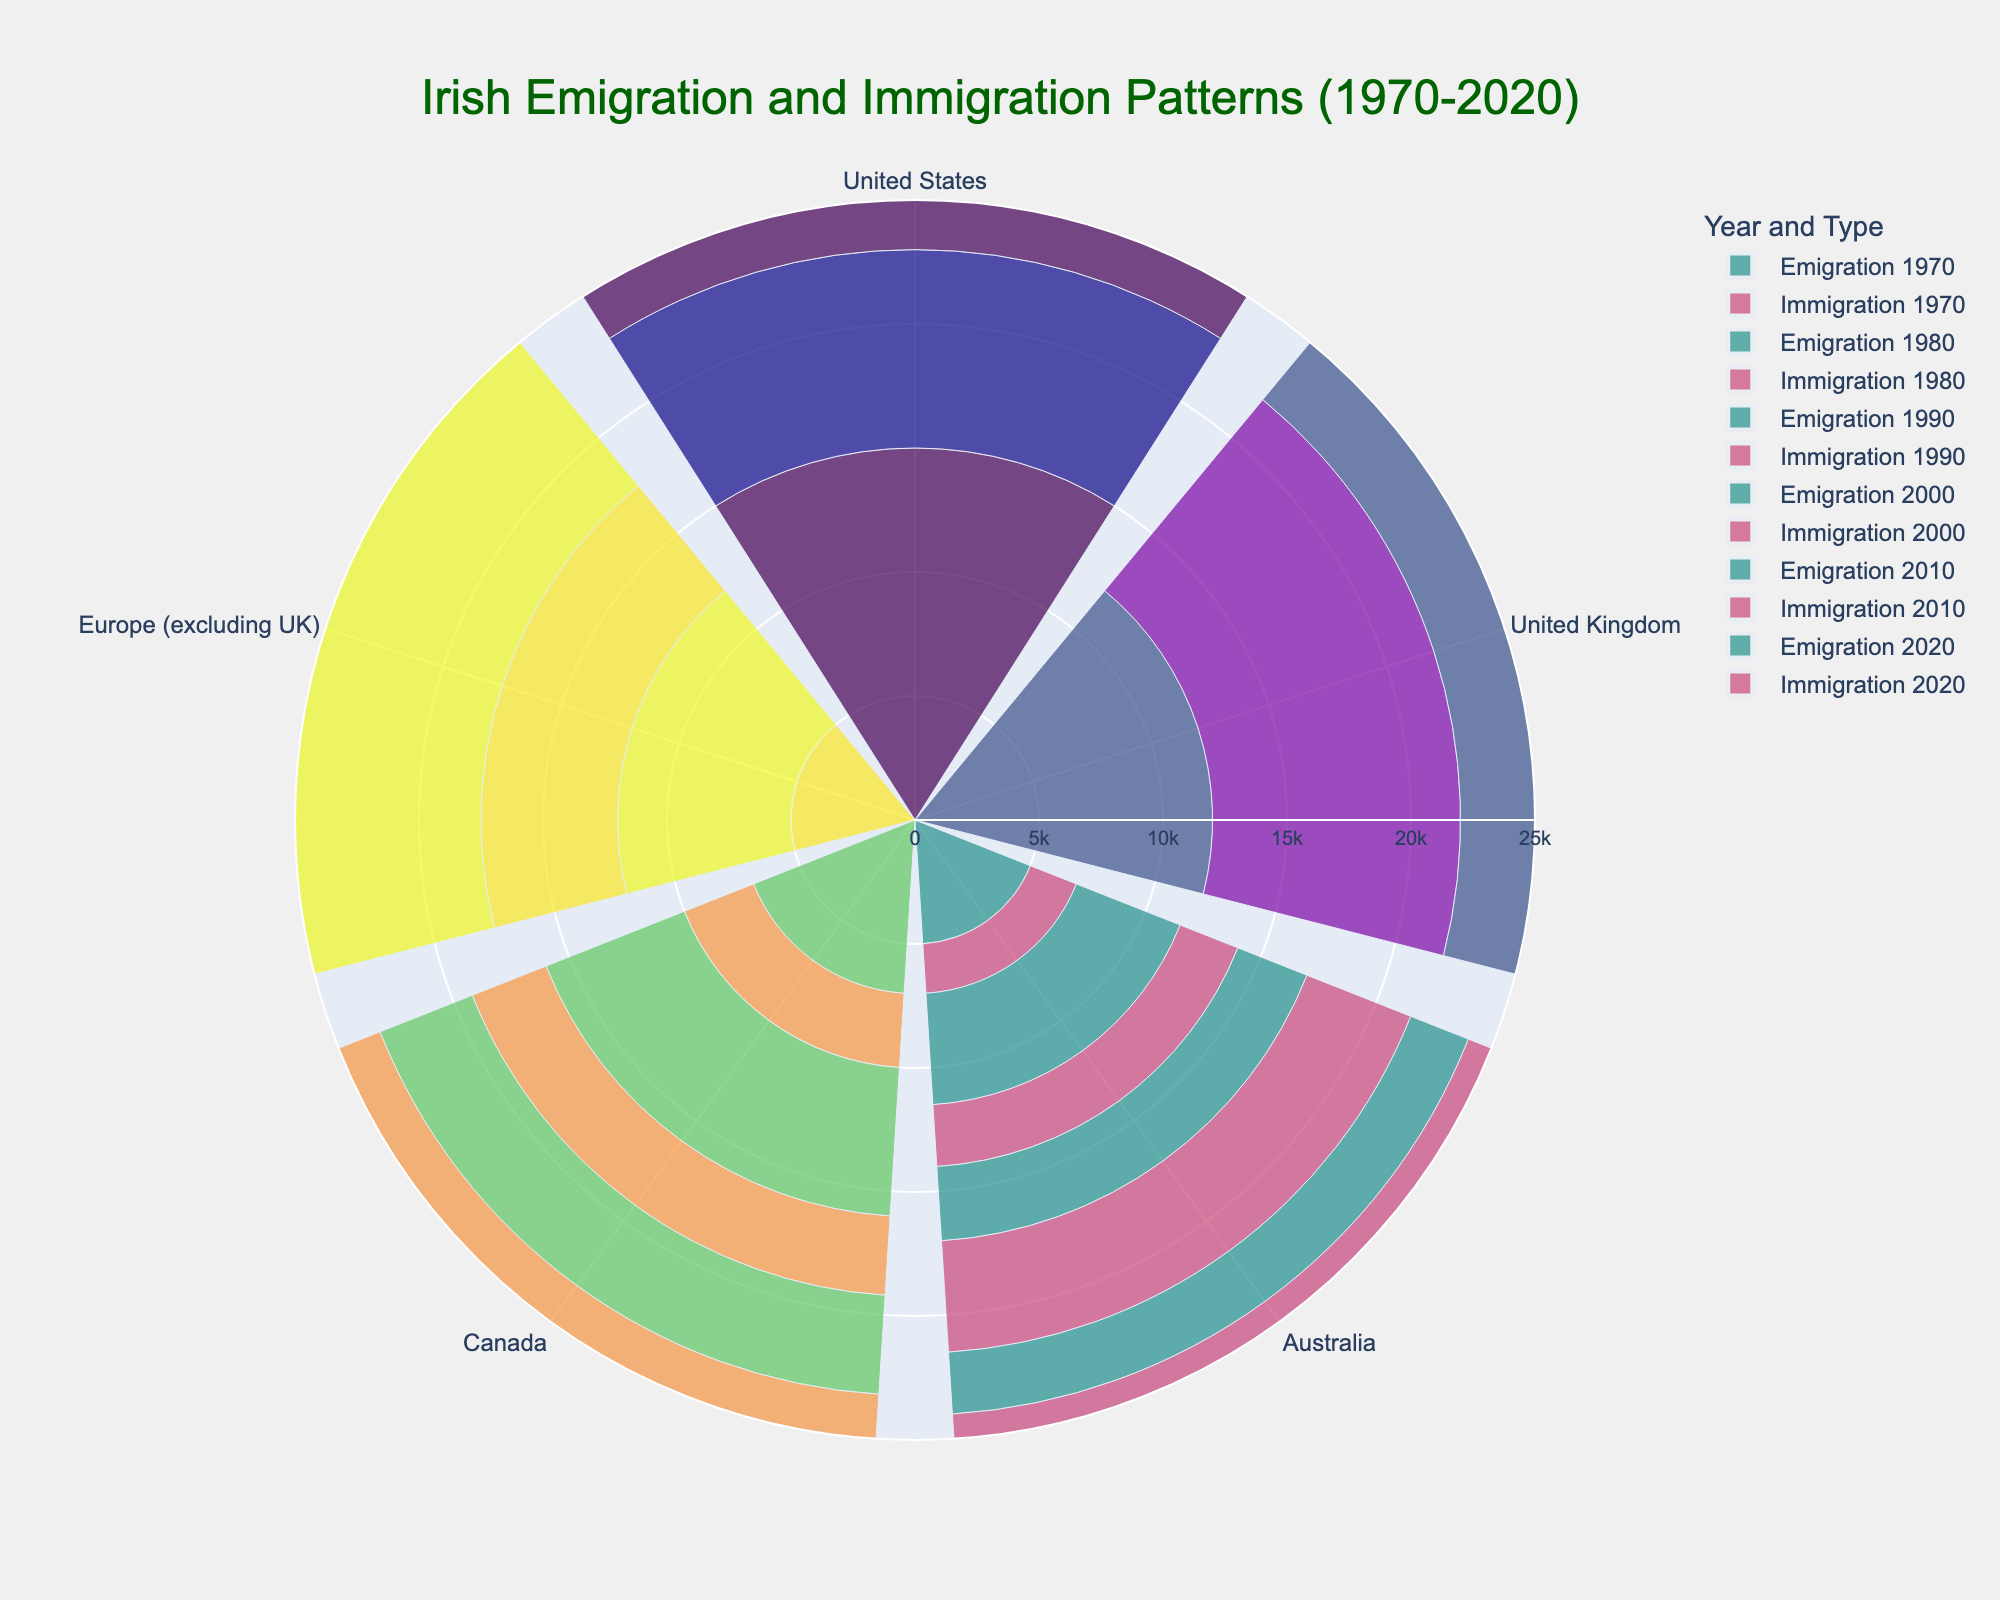What's the title of the chart? At the top of the chart, there is a text box that provides the title, which summarizes the content of the chart.
Answer: Irish Emigration and Immigration Patterns (1970-2020) How many regions are shown in the chart? The chart divides the data into segments, each representing a region. By counting these segments, we can determine the number of regions.
Answer: 5 Which region had the highest immigration in 2020? The bar segments labeled "Immigration 2020" extend outwards from the center. By identifying the longest bar, we can determine which region had the highest immigration.
Answer: United States What is the difference in emigration between the United Kingdom and Europe (excluding UK) in 2010? Look at the "Emigration 2010" bars for both regions and subtract the value of Europe (excluding UK) from the United Kingdom.
Answer: -1000 Which year did Canada have higher immigration compared to emigration most significantly? Compare the lengths of the "Immigration" and "Emigration" bars for Canada across all years. Identify the year with the largest difference where immigration is greater than emigration.
Answer: 2000 In which year did Australia see the least emigration? Look at the "Emigration" bars for Australia in all years and find the shortest bar.
Answer: 2020 What was the pattern of emigration to the United States from 1970 to 2020? Observe the "Emigration" bars for the United States over the years and note the trend or pattern shown.
Answer: Decreasing Which region had equal emigration and immigration in 1970? Compare the lengths of the "Emigration 1970" and "Immigration 1970" bars for all regions. Identify the region where both bars are of equal length.
Answer: Europe (excluding UK) What was the sum of immigrations to Canada in 1980 and 2000? Look at the "Immigration" bars for Canada for the years 1980 and 2000, then add these values together.
Answer: 10,200 How did the immigration to Europe (excluding UK) change from 1980 to 2020? Compare the "Immigration" bars for Europe (excluding UK) between 1980 and 2020 and describe the change.
Answer: Increased 